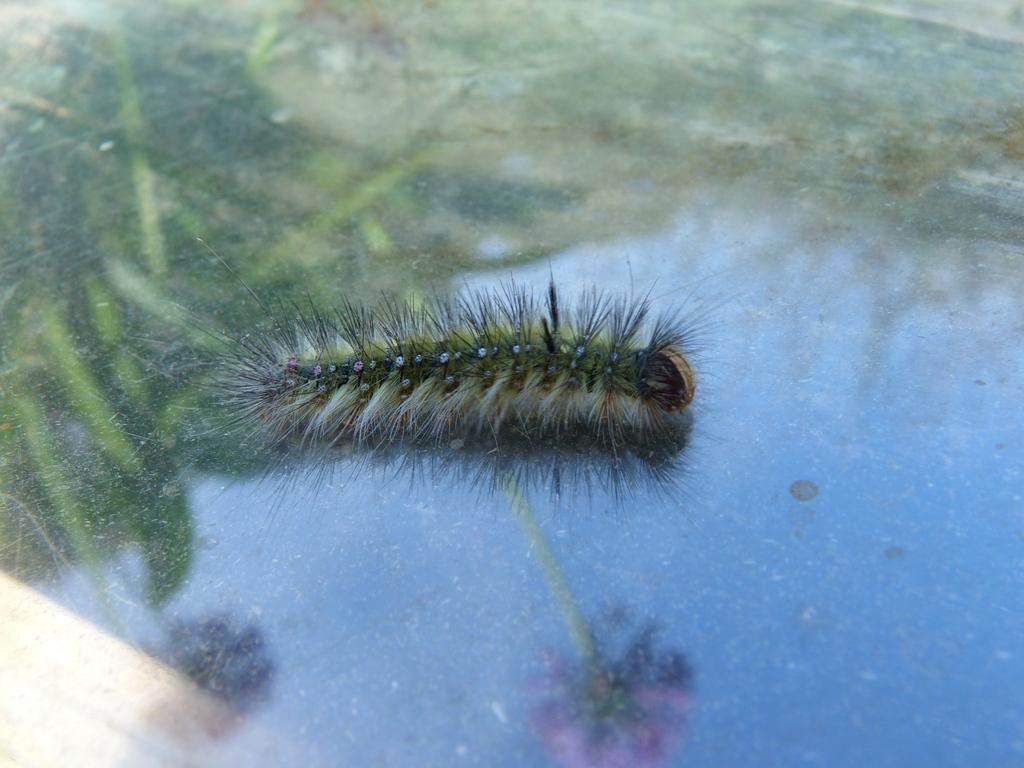What type of creature can be seen in the image? There is an insect in the image. Where is the insect located in the image? The insect is on an object that resembles a glass. What can be seen in the reflections on the object? The object has reflections of plants, flowers, and the sky. What scientific experiment is being conducted in the image? There is no indication of a scientific experiment being conducted in the image; it simply shows an insect on an object with reflections. 